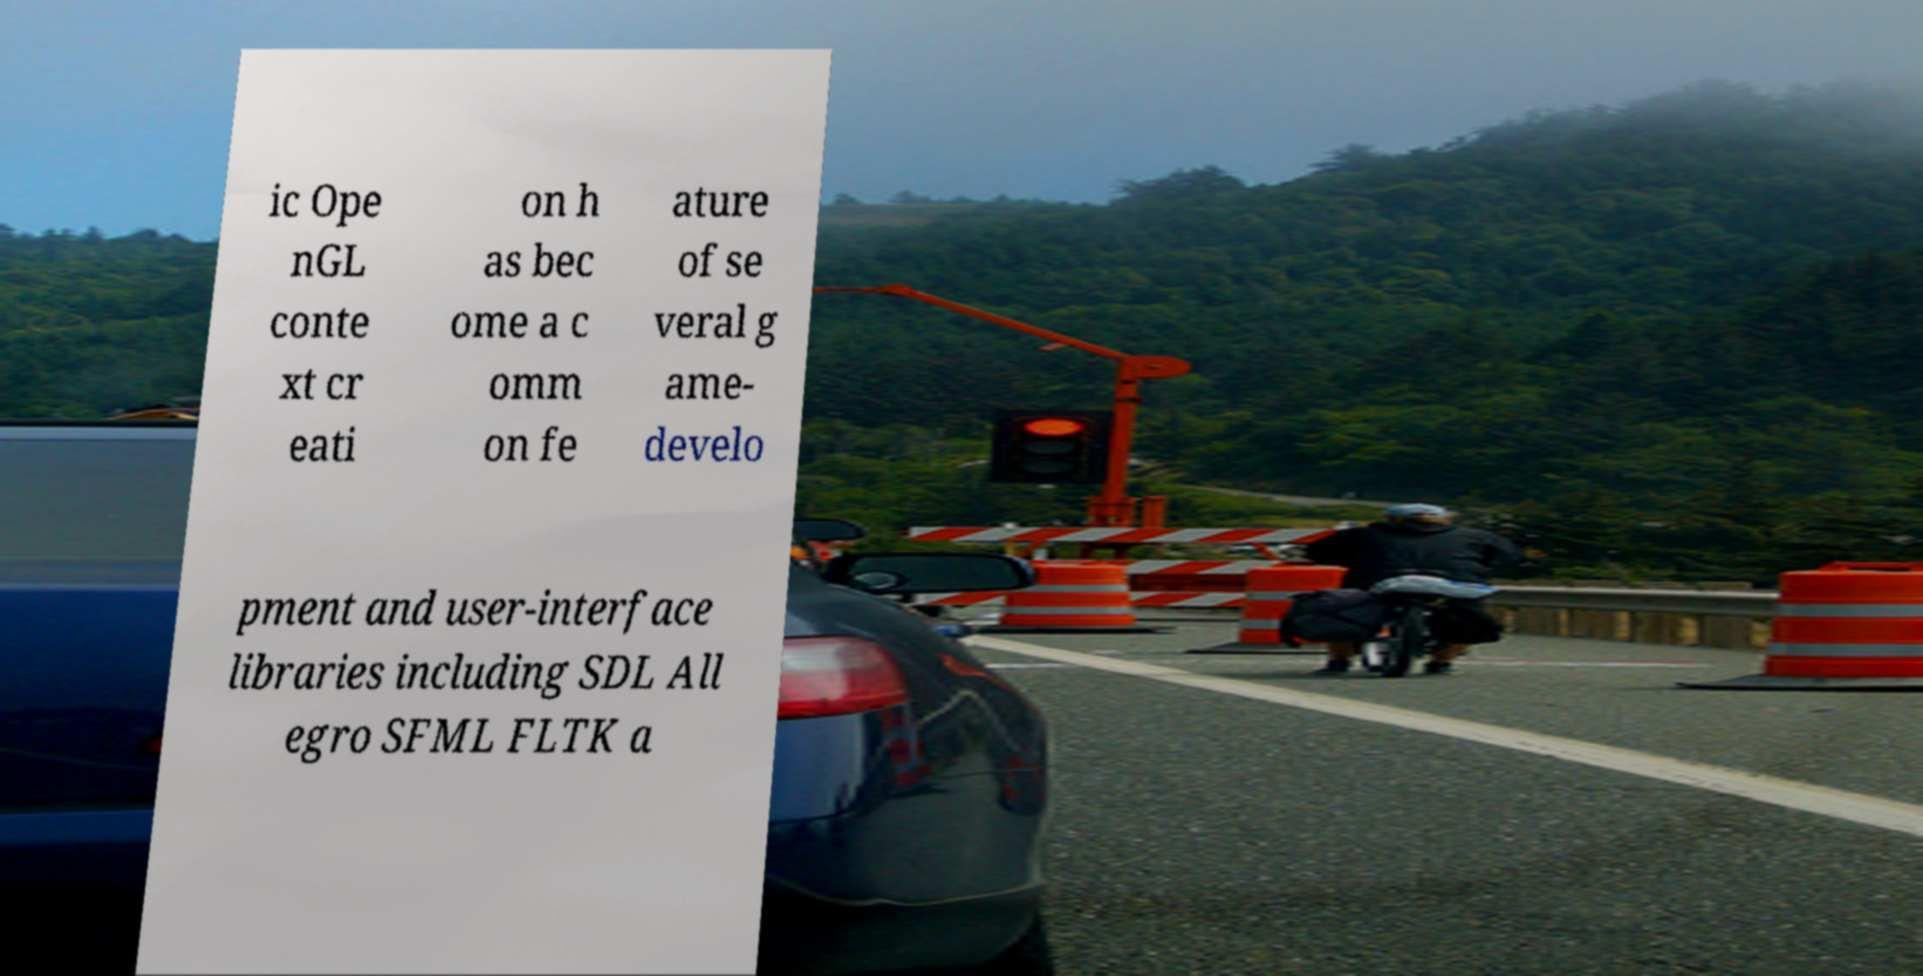I need the written content from this picture converted into text. Can you do that? ic Ope nGL conte xt cr eati on h as bec ome a c omm on fe ature of se veral g ame- develo pment and user-interface libraries including SDL All egro SFML FLTK a 